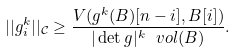Convert formula to latex. <formula><loc_0><loc_0><loc_500><loc_500>| | g _ { i } ^ { k } | | _ { \mathcal { C } } \geq \frac { V ( g ^ { k } ( B ) [ n - i ] , B [ i ] ) } { | \det g | ^ { k } \ v o l ( B ) } .</formula> 